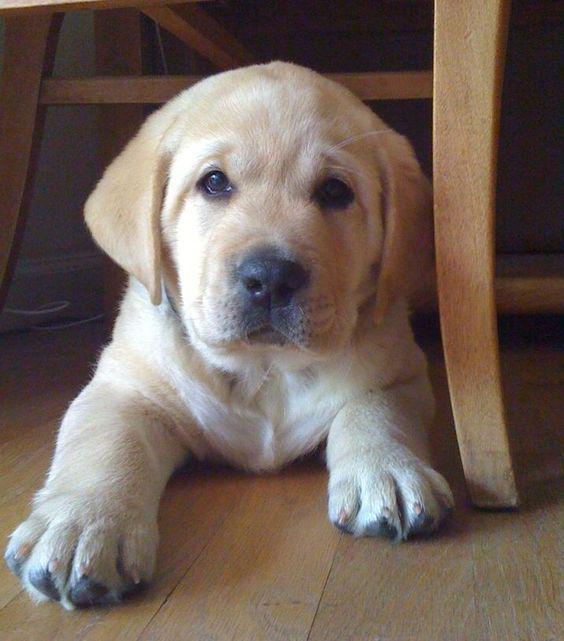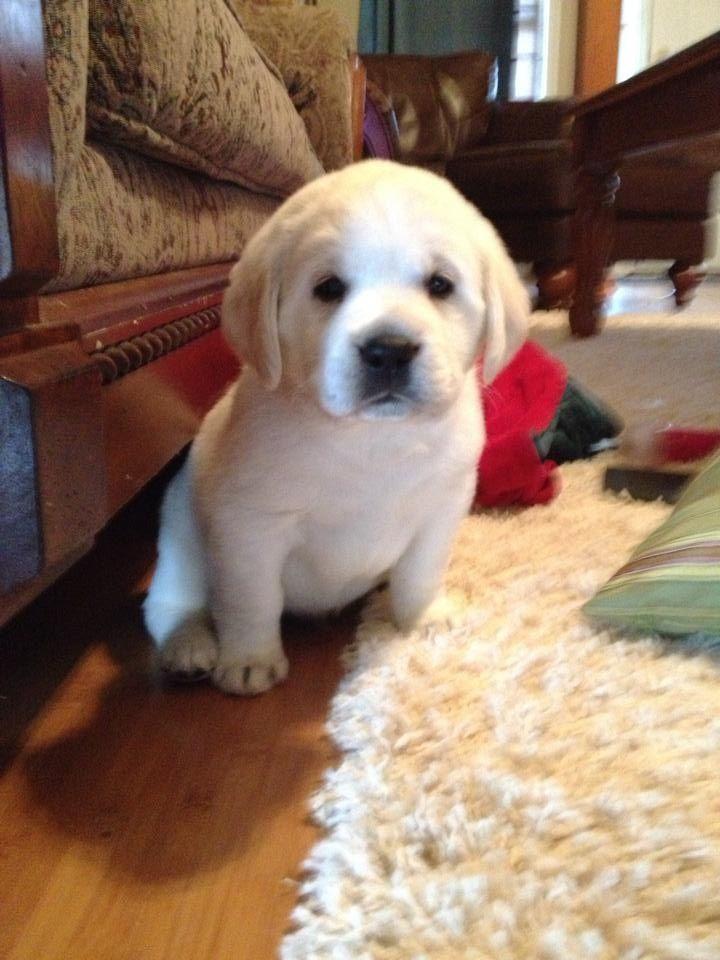The first image is the image on the left, the second image is the image on the right. Evaluate the accuracy of this statement regarding the images: "The left image contains one dog laying on wooden flooring.". Is it true? Answer yes or no. Yes. The first image is the image on the left, the second image is the image on the right. For the images shown, is this caption "Each image contains one dog, and every dog is a """"blond"""" puppy." true? Answer yes or no. Yes. 